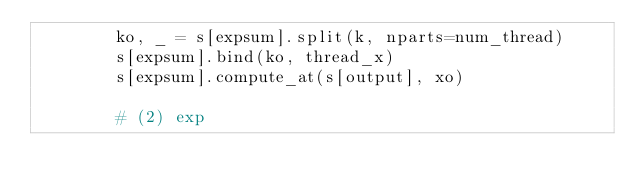Convert code to text. <code><loc_0><loc_0><loc_500><loc_500><_Python_>        ko, _ = s[expsum].split(k, nparts=num_thread)
        s[expsum].bind(ko, thread_x)
        s[expsum].compute_at(s[output], xo)

        # (2) exp</code> 